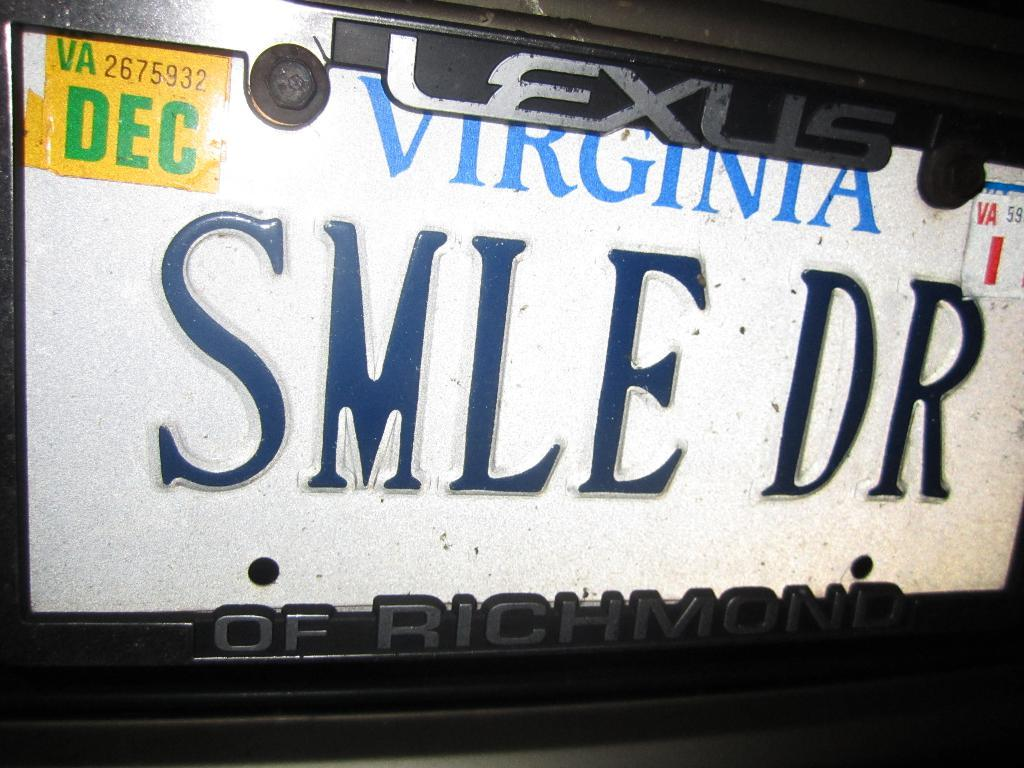<image>
Write a terse but informative summary of the picture. A Virginia license plate with the letters SMLE DR on it 